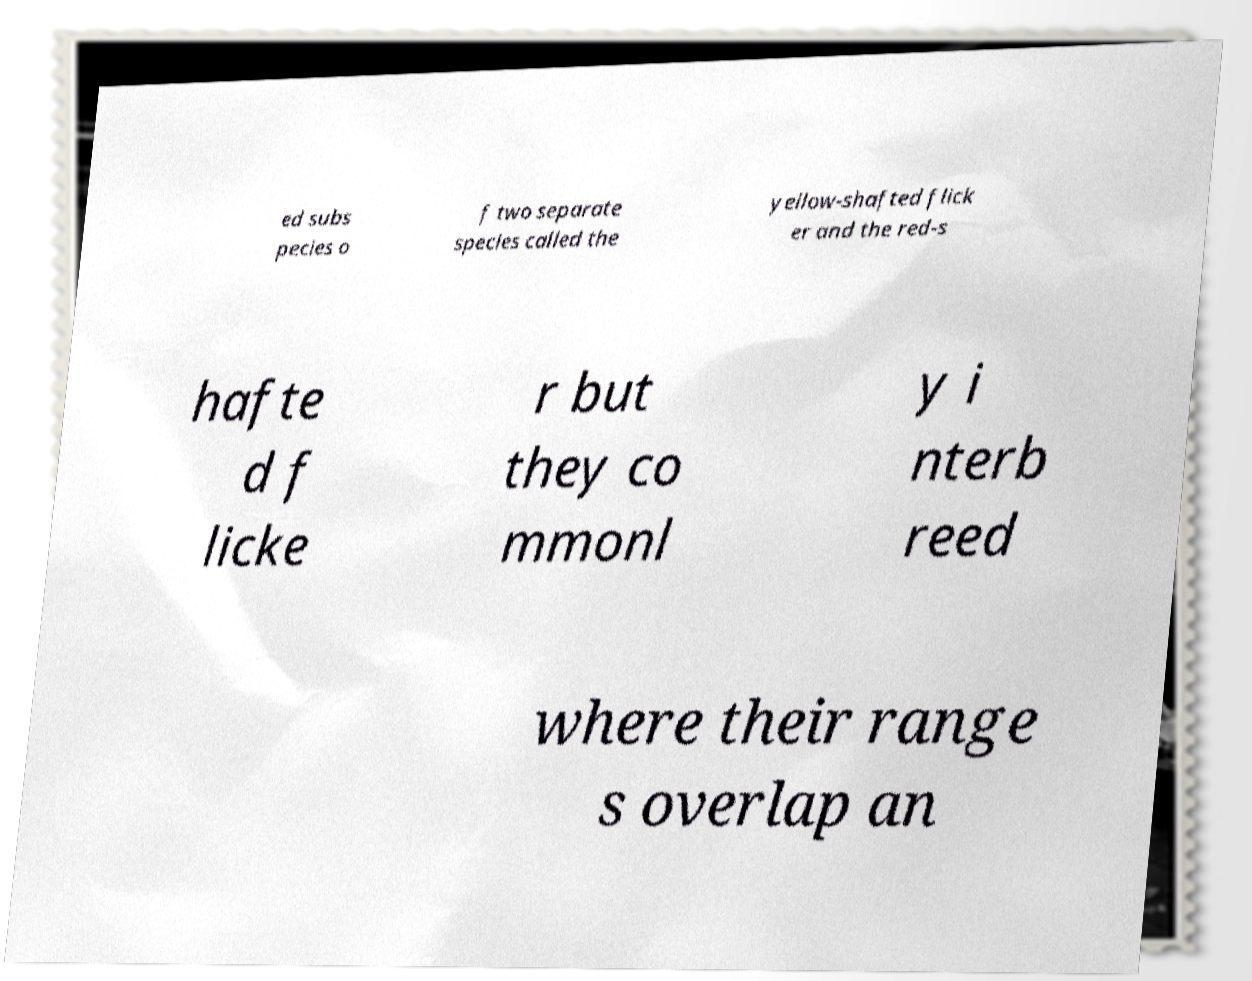What messages or text are displayed in this image? I need them in a readable, typed format. ed subs pecies o f two separate species called the yellow-shafted flick er and the red-s hafte d f licke r but they co mmonl y i nterb reed where their range s overlap an 